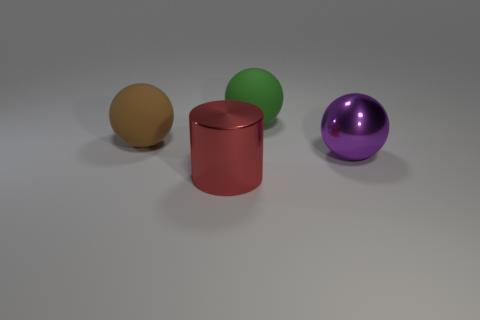What number of things are either big objects that are behind the large brown rubber thing or objects that are behind the big red shiny cylinder?
Your response must be concise. 3. There is a object on the right side of the large green matte object; is there a big ball left of it?
Your answer should be compact. Yes. There is a red metal object that is the same size as the brown ball; what shape is it?
Provide a succinct answer. Cylinder. What number of things are either metal objects that are right of the large red thing or rubber spheres?
Your response must be concise. 3. What number of other things are there of the same material as the purple thing
Your response must be concise. 1. There is a rubber ball that is on the right side of the big red thing; what size is it?
Provide a short and direct response. Large. There is a big red object that is made of the same material as the purple ball; what shape is it?
Keep it short and to the point. Cylinder. Do the brown object and the large object that is behind the brown ball have the same material?
Offer a terse response. Yes. Is the shape of the large brown matte object that is to the left of the big purple thing the same as  the big green object?
Offer a terse response. Yes. There is a green thing that is the same shape as the large purple thing; what material is it?
Your answer should be compact. Rubber. 